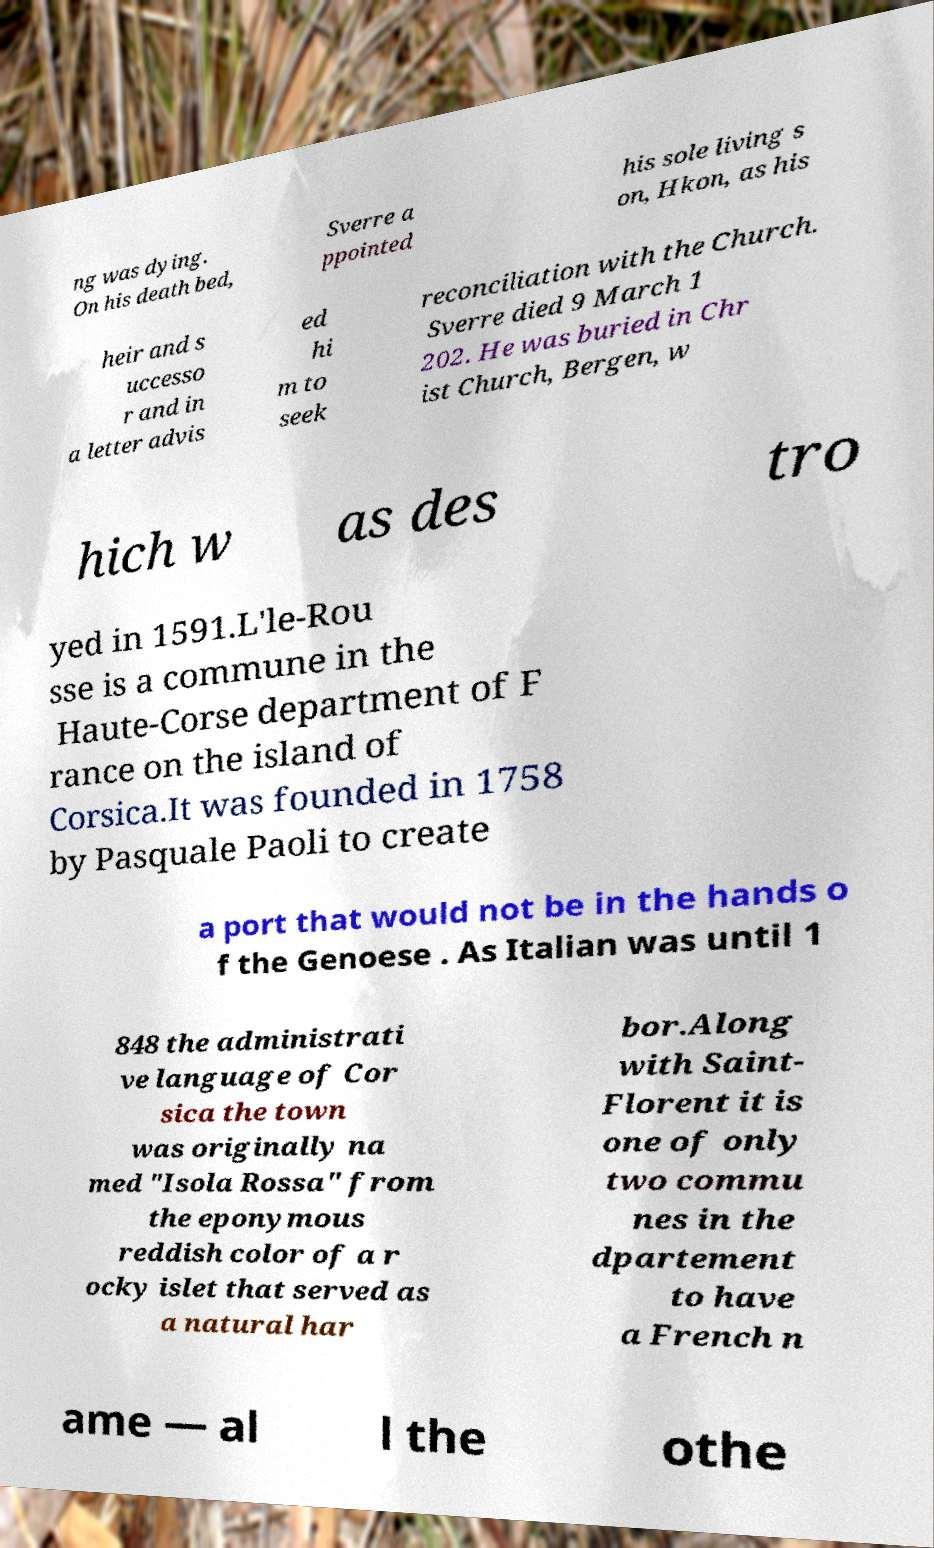Please identify and transcribe the text found in this image. ng was dying. On his death bed, Sverre a ppointed his sole living s on, Hkon, as his heir and s uccesso r and in a letter advis ed hi m to seek reconciliation with the Church. Sverre died 9 March 1 202. He was buried in Chr ist Church, Bergen, w hich w as des tro yed in 1591.L'le-Rou sse is a commune in the Haute-Corse department of F rance on the island of Corsica.It was founded in 1758 by Pasquale Paoli to create a port that would not be in the hands o f the Genoese . As Italian was until 1 848 the administrati ve language of Cor sica the town was originally na med "Isola Rossa" from the eponymous reddish color of a r ocky islet that served as a natural har bor.Along with Saint- Florent it is one of only two commu nes in the dpartement to have a French n ame — al l the othe 